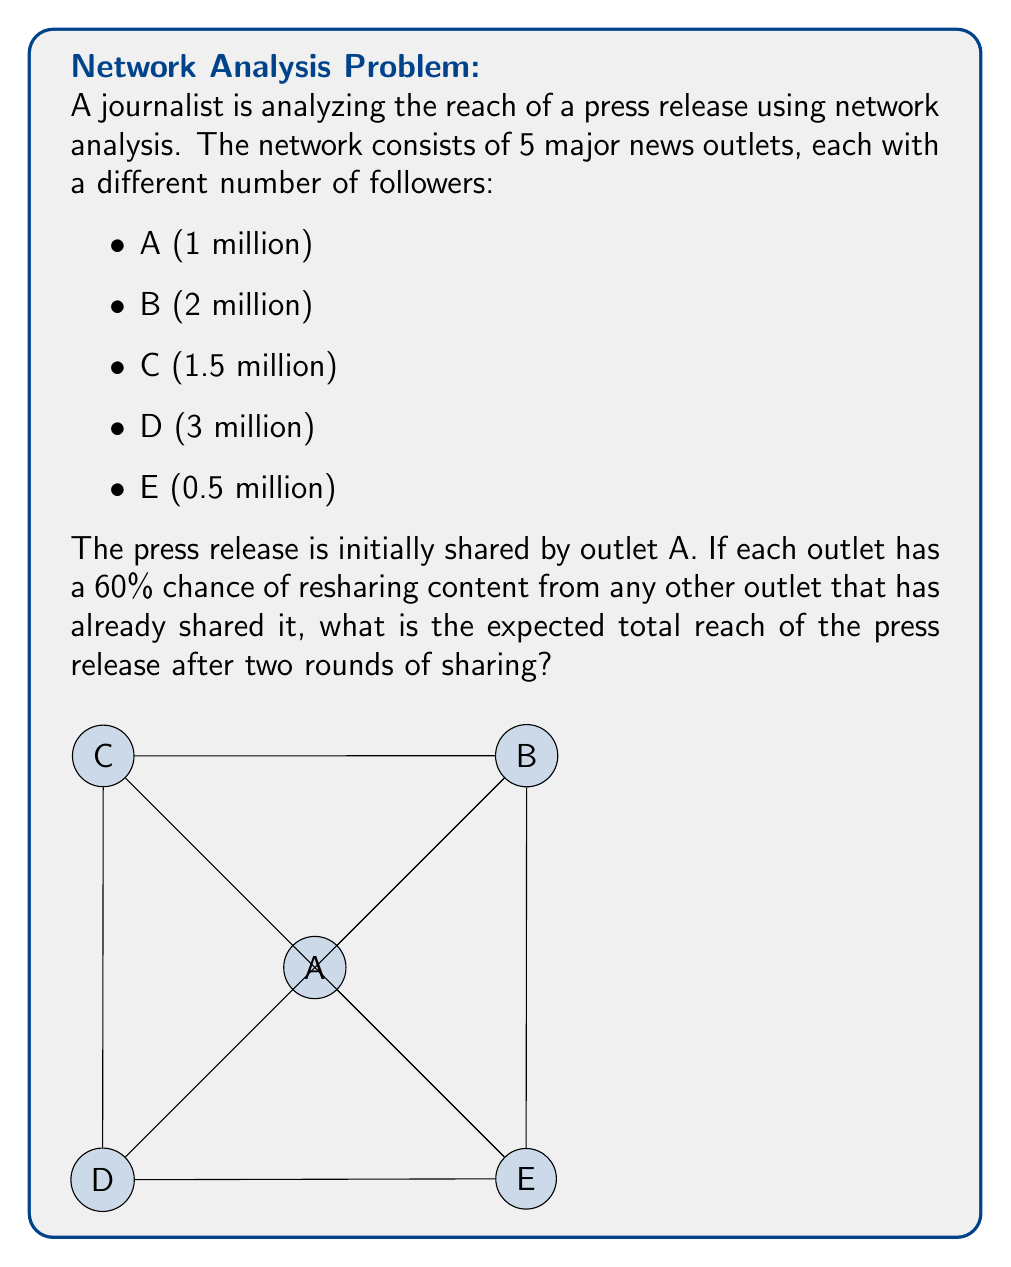Provide a solution to this math problem. Let's approach this step-by-step:

1) In the first round, outlet A shares the press release, reaching 1 million followers.

2) For the second round, we need to calculate the probability of each other outlet sharing:
   $P(\text{sharing}) = 1 - P(\text{not sharing}) = 1 - (1-0.6)^1 = 0.6$

3) The expected number of additional outlets sharing in the second round is:
   $E(\text{additional outlets}) = 0.6 \times 4 = 2.4$

4) To calculate the expected reach, we need to consider all possible outcomes:
   - Probability of 0 additional outlets: $P(0) = \binom{4}{0}0.6^0(0.4)^4 = 0.0256$
   - Probability of 1 additional outlet: $P(1) = \binom{4}{1}0.6^1(0.4)^3 = 0.1536$
   - Probability of 2 additional outlets: $P(2) = \binom{4}{2}0.6^2(0.4)^2 = 0.3456$
   - Probability of 3 additional outlets: $P(3) = \binom{4}{3}0.6^3(0.4)^1 = 0.3456$
   - Probability of 4 additional outlets: $P(4) = \binom{4}{4}0.6^4(0.4)^0 = 0.1296$

5) The expected reach for each case:
   - 0 additional: $1M$
   - 1 additional: $1M + 2M = 3M$ (assuming B is most likely due to highest followers)
   - 2 additional: $1M + 2M + 3M = 6M$ (assuming B and D)
   - 3 additional: $1M + 2M + 3M + 1.5M = 7.5M$ (assuming B, D, and C)
   - 4 additional: $1M + 2M + 3M + 1.5M + 0.5M = 8M$

6) The expected total reach is:
   $$E(\text{reach}) = 1M \times 0.0256 + 3M \times 0.1536 + 6M \times 0.3456 + 7.5M \times 0.3456 + 8M \times 0.1296$$
   $$= 0.0256M + 0.4608M + 2.0736M + 2.592M + 1.0368M = 6.1888M$$

Therefore, the expected total reach after two rounds of sharing is approximately 6.19 million followers.
Answer: 6.19 million followers 